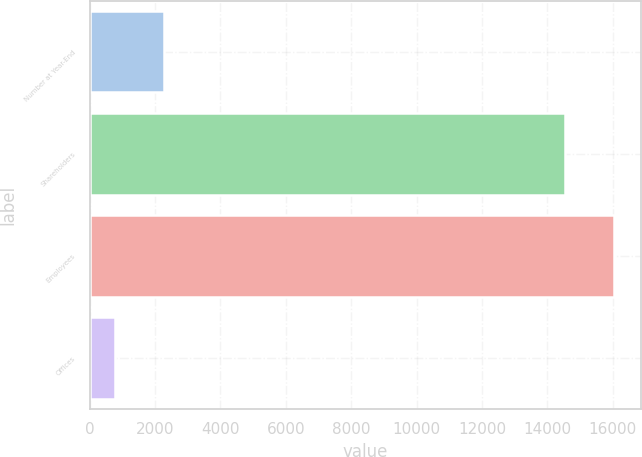Convert chart to OTSL. <chart><loc_0><loc_0><loc_500><loc_500><bar_chart><fcel>Number at Year-End<fcel>Shareholders<fcel>Employees<fcel>Offices<nl><fcel>2267.6<fcel>14551<fcel>16052.6<fcel>766<nl></chart> 